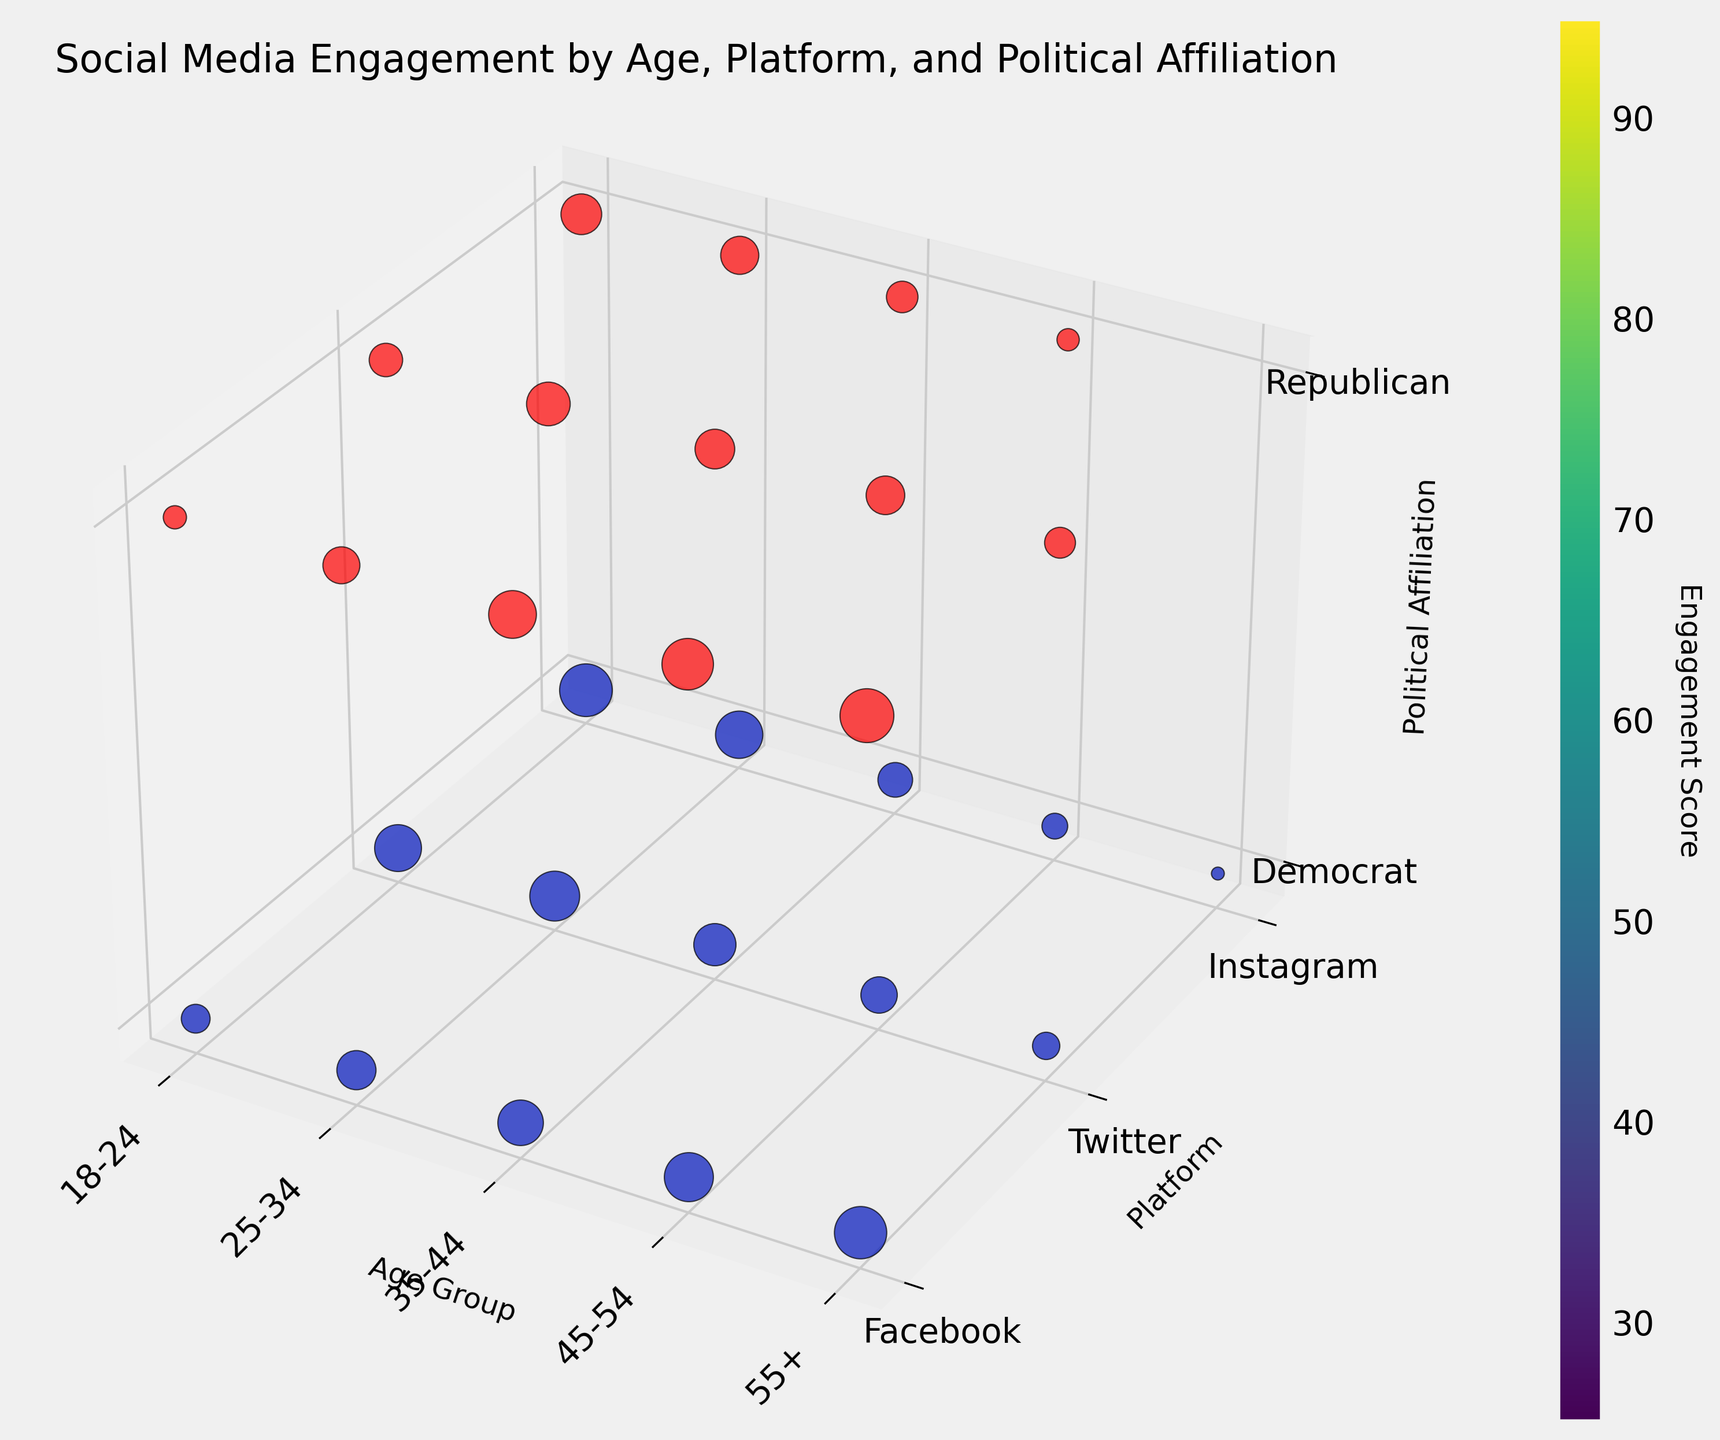What is the title of the figure? The title of the figure is written at the top of the plot titled 'Social Media Engagement by Age, Platform, and Political Affiliation'.
Answer: Social Media Engagement by Age, Platform, and Political Affiliation Which age group shows the highest engagement for Democrats on Instagram? To find the highest engagement for Democrats on Instagram, we need to look at the Democrat voxels for the Instagram platform across all age groups. The largest voxel appears under the 18-24 age category for Instagram, indicating the highest engagement score.
Answer: 18-24 Compare the engagement scores for Republicans on Facebook and Twitter in the 55+ age group. Which platform has a higher engagement score? To compare the engagement, we should refer to the 55+ age group voxels for Facebook and Twitter under Republican affiliation. The size of the voxel for Facebook is larger than that for Twitter, indicating a higher engagement score on Facebook.
Answer: Facebook What’s the overall trend in engagement scores for Republicans across different age groups on Instagram? To determine the trend, we need to examine the Republican voxels for Instagram across all age groups. The engagement scores on Instagram for Republicans decrease as age increases. This trend is visualized by the decreasing size of voxels from 18-24 to 55+.
Answer: Decreasing In which age group do Democrats show higher engagement than Republicans on Twitter? By comparing voxel sizes for Democrats and Republicans on Twitter across all age groups, the 18-24 and 25-34 age groups show larger Democrat voxels on Twitter, indicating higher engagement scores compared to Republicans.
Answer: 18-24, 25-34 Which political affiliation shows more variability in engagement scores across different social media platforms in the 25-34 age group? To find variability, check the range of engagement scores for each platform under the 25-34 age group for both affiliations. The Democrats' voxels vary significantly in size across platforms (Facebook, Twitter, Instagram), while Republicans’ voxels are more consistent in size. This indicates higher variability for Democrats.
Answer: Democrat What is the engagement score normalization range used in the plot? The normalization range used in the plot is obtained by observing the minimum and maximum engagement scores in the dataset and transforming them to a range [0, 1]. The minimum score is 25, and the maximum score is 95, so the normalization range reflects these values being mapped to 0 and 1 respectively.
Answer: 0 to 1 How does engagement on Instagram vary between the 18-24 age group and the 55+ age group for both political affiliations? To compare Instagram engagement, observe the voxel sizes for both Democrats and Republicans in the 18-24 and 55+ age groups. For Democrats, it decreases from 18-24 to 55+ (92 to 29). For Republicans, it also decreases (65 to 25). Hence, engagement significantly drops from younger to older age groups for both affiliations.
Answer: It decreases for both Which social media platform has the highest engagement score for Republicans in the 35-44 age group? To identify this, look at the voxel sizes for Republicans in the 35-44 age group across Facebook, Twitter, and Instagram. The largest voxel appears for Facebook, implying the highest engagement score.
Answer: Facebook Is there any platform where both political affiliations have almost equal engagement scores in the 45-54 age group? By comparing the voxel sizes for both Democrats and Republicans in the 45-54 age groups across all platforms, the closest in size appear to be Twitter, where the engagement scores (57 for Democrats and 61 for Republicans) are nearly equal.
Answer: Twitter 